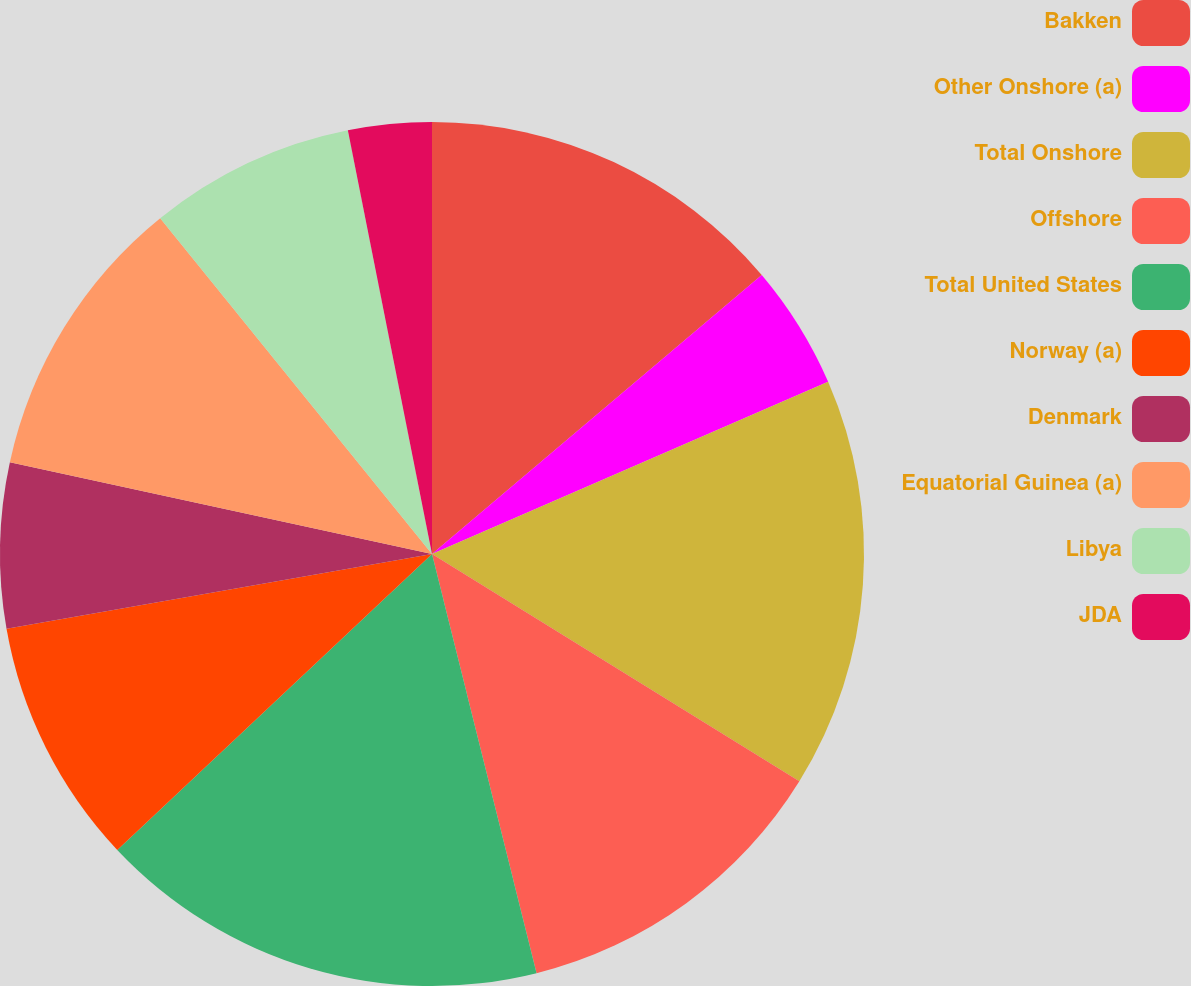Convert chart. <chart><loc_0><loc_0><loc_500><loc_500><pie_chart><fcel>Bakken<fcel>Other Onshore (a)<fcel>Total Onshore<fcel>Offshore<fcel>Total United States<fcel>Norway (a)<fcel>Denmark<fcel>Equatorial Guinea (a)<fcel>Libya<fcel>JDA<nl><fcel>13.82%<fcel>4.65%<fcel>15.35%<fcel>12.29%<fcel>16.88%<fcel>9.24%<fcel>6.18%<fcel>10.76%<fcel>7.71%<fcel>3.12%<nl></chart> 